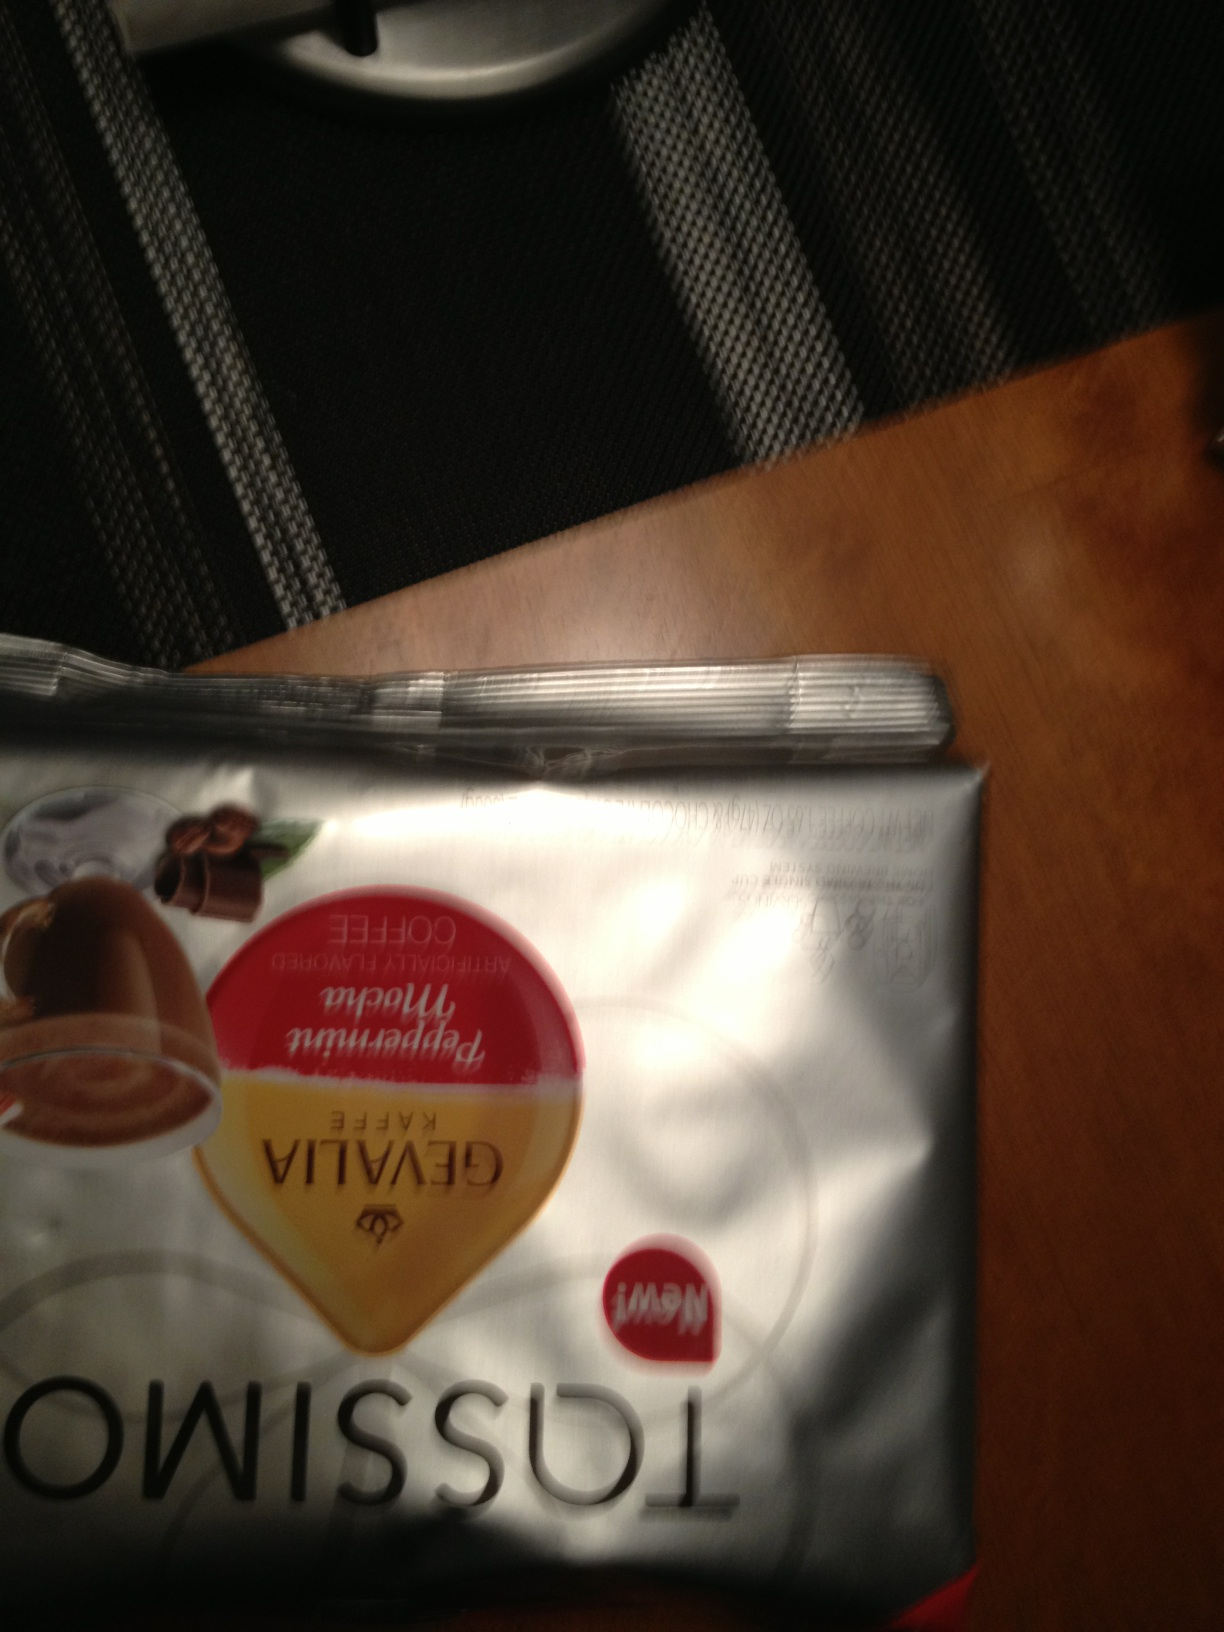What kind of flavors might I expect from this brand of coffee? Gevalia coffee boasts a wide range of nuanced flavors, typically characterized by a smooth, rich, and never bitter taste. Depending on the blend, you might notice hints of cocoa, caramel, or even slight citrus notes. This particular blend, judging by the packaging, seems to promise a creamy and indulgent experience, perhaps with chocolatey undertones, making it perfect for a luxurious latte or robust cappuccino. 